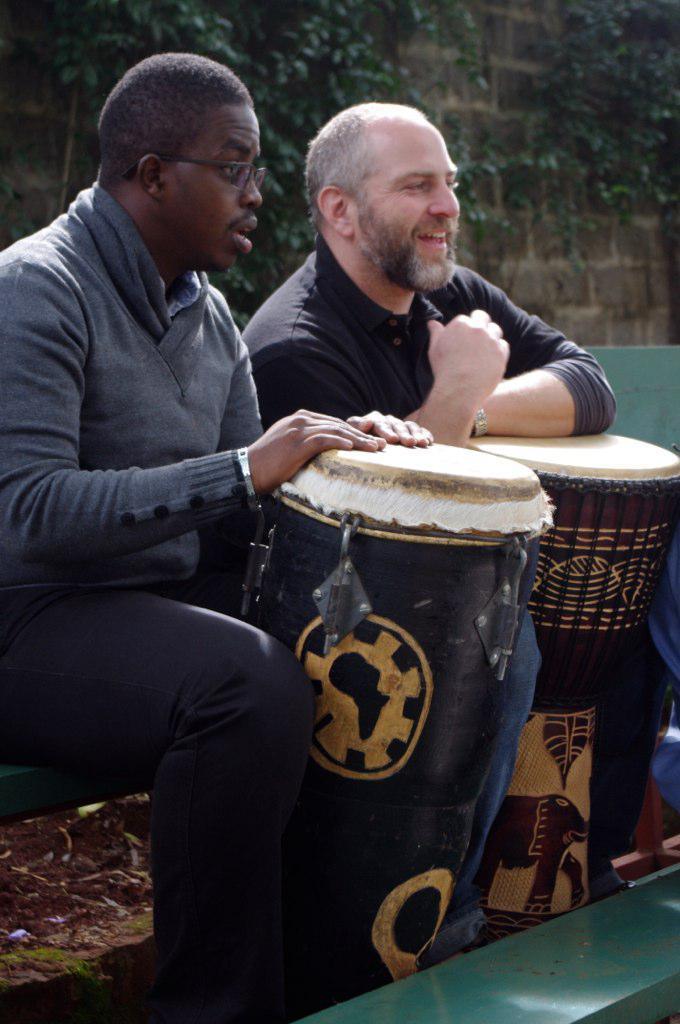Could you give a brief overview of what you see in this image? In the image there are two men and there are two drums in front of them, behind the men there is a wall and on the wall there are branches of trees. 